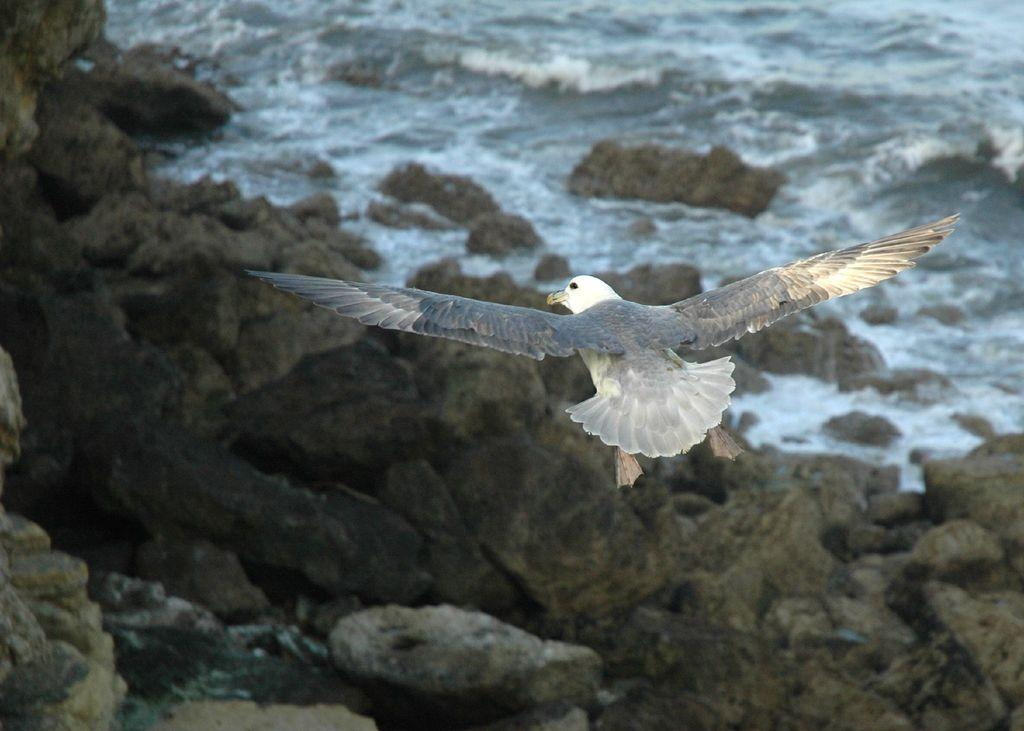What is the main subject in the foreground of the image? There is a bird in the foreground of the image. What is the bird doing in the image? The bird is in the air. What can be seen in the background of the image? There are rocks and water visible in the background of the image. What type of fireman is present in the image? There is no fireman present in the image; it features a bird in the air. What is the bird's afterthought while flying in the image? The image does not provide information about the bird's thoughts or afterthoughts. --- Facts: 1. There is a person sitting on a bench in the image. 2. The person is reading a book. 3. There is a tree behind the bench. 4. The sky is visible in the image. Absurd Topics: elephant, dance, ocean Conversation: What is the person in the image doing? The person is sitting on a bench in the image. What activity is the person engaged in while sitting on the bench? The person is reading a book. What can be seen behind the bench in the image? There is a tree behind the bench. What is visible in the sky in the image? The sky is visible in the image. Reasoning: Let's think step by step in order to produce the conversation. We start by identifying the main subject in the image, which is the person sitting on the bench. Then, we describe the person's activity, which is reading a book. Next, we mention the background elements, which are a tree and the sky. Each question is designed to elicit a specific detail about the image that is known from the provided facts. Absurd Question/Answer: Can you see any elephants dancing in the ocean in the image? There are no elephants or ocean present in the image; it features a person sitting on a bench reading a book. 